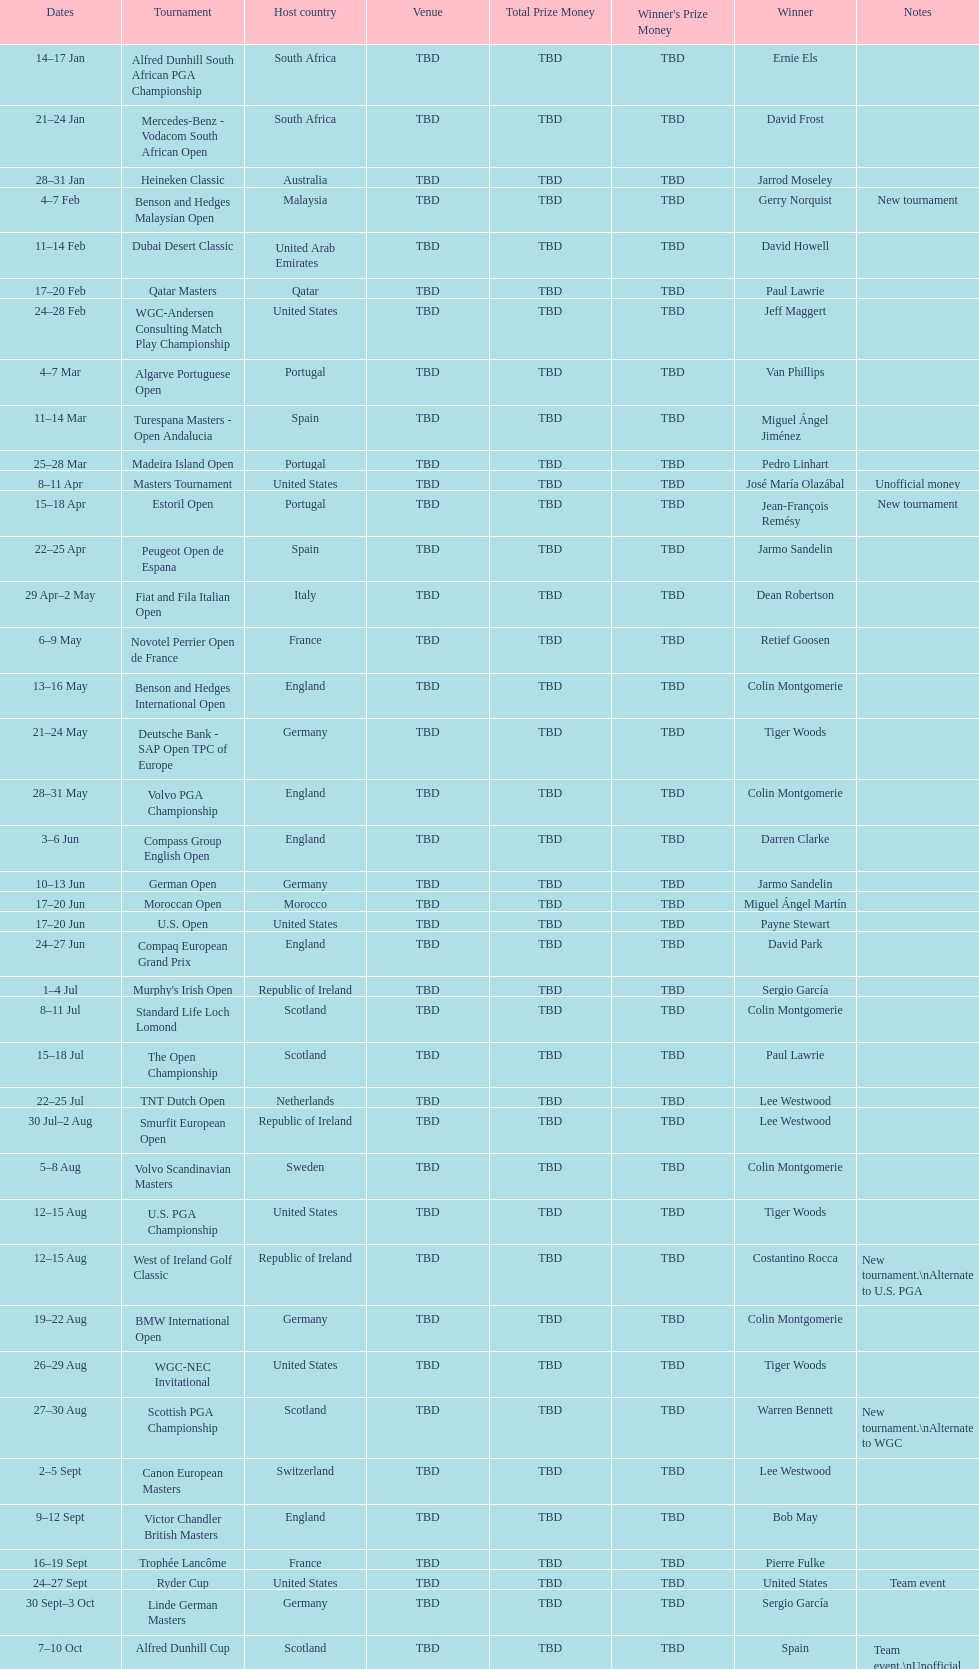I'm looking to parse the entire table for insights. Could you assist me with that? {'header': ['Dates', 'Tournament', 'Host country', 'Venue', 'Total Prize Money', "Winner's Prize Money", 'Winner', 'Notes'], 'rows': [['14–17\xa0Jan', 'Alfred Dunhill South African PGA Championship', 'South Africa', 'TBD', 'TBD', 'TBD', 'Ernie Els', ''], ['21–24\xa0Jan', 'Mercedes-Benz - Vodacom South African Open', 'South Africa', 'TBD', 'TBD', 'TBD', 'David Frost', ''], ['28–31\xa0Jan', 'Heineken Classic', 'Australia', 'TBD', 'TBD', 'TBD', 'Jarrod Moseley', ''], ['4–7\xa0Feb', 'Benson and Hedges Malaysian Open', 'Malaysia', 'TBD', 'TBD', 'TBD', 'Gerry Norquist', 'New tournament'], ['11–14\xa0Feb', 'Dubai Desert Classic', 'United Arab Emirates', 'TBD', 'TBD', 'TBD', 'David Howell', ''], ['17–20\xa0Feb', 'Qatar Masters', 'Qatar', 'TBD', 'TBD', 'TBD', 'Paul Lawrie', ''], ['24–28\xa0Feb', 'WGC-Andersen Consulting Match Play Championship', 'United States', 'TBD', 'TBD', 'TBD', 'Jeff Maggert', ''], ['4–7\xa0Mar', 'Algarve Portuguese Open', 'Portugal', 'TBD', 'TBD', 'TBD', 'Van Phillips', ''], ['11–14\xa0Mar', 'Turespana Masters - Open Andalucia', 'Spain', 'TBD', 'TBD', 'TBD', 'Miguel Ángel Jiménez', ''], ['25–28\xa0Mar', 'Madeira Island Open', 'Portugal', 'TBD', 'TBD', 'TBD', 'Pedro Linhart', ''], ['8–11\xa0Apr', 'Masters Tournament', 'United States', 'TBD', 'TBD', 'TBD', 'José María Olazábal', 'Unofficial money'], ['15–18\xa0Apr', 'Estoril Open', 'Portugal', 'TBD', 'TBD', 'TBD', 'Jean-François Remésy', 'New tournament'], ['22–25\xa0Apr', 'Peugeot Open de Espana', 'Spain', 'TBD', 'TBD', 'TBD', 'Jarmo Sandelin', ''], ['29\xa0Apr–2\xa0May', 'Fiat and Fila Italian Open', 'Italy', 'TBD', 'TBD', 'TBD', 'Dean Robertson', ''], ['6–9\xa0May', 'Novotel Perrier Open de France', 'France', 'TBD', 'TBD', 'TBD', 'Retief Goosen', ''], ['13–16\xa0May', 'Benson and Hedges International Open', 'England', 'TBD', 'TBD', 'TBD', 'Colin Montgomerie', ''], ['21–24\xa0May', 'Deutsche Bank - SAP Open TPC of Europe', 'Germany', 'TBD', 'TBD', 'TBD', 'Tiger Woods', ''], ['28–31\xa0May', 'Volvo PGA Championship', 'England', 'TBD', 'TBD', 'TBD', 'Colin Montgomerie', ''], ['3–6\xa0Jun', 'Compass Group English Open', 'England', 'TBD', 'TBD', 'TBD', 'Darren Clarke', ''], ['10–13\xa0Jun', 'German Open', 'Germany', 'TBD', 'TBD', 'TBD', 'Jarmo Sandelin', ''], ['17–20\xa0Jun', 'Moroccan Open', 'Morocco', 'TBD', 'TBD', 'TBD', 'Miguel Ángel Martín', ''], ['17–20\xa0Jun', 'U.S. Open', 'United States', 'TBD', 'TBD', 'TBD', 'Payne Stewart', ''], ['24–27\xa0Jun', 'Compaq European Grand Prix', 'England', 'TBD', 'TBD', 'TBD', 'David Park', ''], ['1–4\xa0Jul', "Murphy's Irish Open", 'Republic of Ireland', 'TBD', 'TBD', 'TBD', 'Sergio García', ''], ['8–11\xa0Jul', 'Standard Life Loch Lomond', 'Scotland', 'TBD', 'TBD', 'TBD', 'Colin Montgomerie', ''], ['15–18\xa0Jul', 'The Open Championship', 'Scotland', 'TBD', 'TBD', 'TBD', 'Paul Lawrie', ''], ['22–25\xa0Jul', 'TNT Dutch Open', 'Netherlands', 'TBD', 'TBD', 'TBD', 'Lee Westwood', ''], ['30\xa0Jul–2\xa0Aug', 'Smurfit European Open', 'Republic of Ireland', 'TBD', 'TBD', 'TBD', 'Lee Westwood', ''], ['5–8\xa0Aug', 'Volvo Scandinavian Masters', 'Sweden', 'TBD', 'TBD', 'TBD', 'Colin Montgomerie', ''], ['12–15\xa0Aug', 'U.S. PGA Championship', 'United States', 'TBD', 'TBD', 'TBD', 'Tiger Woods', ''], ['12–15\xa0Aug', 'West of Ireland Golf Classic', 'Republic of Ireland', 'TBD', 'TBD', 'TBD', 'Costantino Rocca', 'New tournament.\\nAlternate to U.S. PGA'], ['19–22\xa0Aug', 'BMW International Open', 'Germany', 'TBD', 'TBD', 'TBD', 'Colin Montgomerie', ''], ['26–29\xa0Aug', 'WGC-NEC Invitational', 'United States', 'TBD', 'TBD', 'TBD', 'Tiger Woods', ''], ['27–30\xa0Aug', 'Scottish PGA Championship', 'Scotland', 'TBD', 'TBD', 'TBD', 'Warren Bennett', 'New tournament.\\nAlternate to WGC'], ['2–5\xa0Sept', 'Canon European Masters', 'Switzerland', 'TBD', 'TBD', 'TBD', 'Lee Westwood', ''], ['9–12\xa0Sept', 'Victor Chandler British Masters', 'England', 'TBD', 'TBD', 'TBD', 'Bob May', ''], ['16–19\xa0Sept', 'Trophée Lancôme', 'France', 'TBD', 'TBD', 'TBD', 'Pierre Fulke', ''], ['24–27\xa0Sept', 'Ryder Cup', 'United States', 'TBD', 'TBD', 'TBD', 'United States', 'Team event'], ['30\xa0Sept–3\xa0Oct', 'Linde German Masters', 'Germany', 'TBD', 'TBD', 'TBD', 'Sergio García', ''], ['7–10\xa0Oct', 'Alfred Dunhill Cup', 'Scotland', 'TBD', 'TBD', 'TBD', 'Spain', 'Team event.\\nUnofficial money'], ['14–17\xa0Oct', 'Cisco World Match Play Championship', 'England', 'TBD', 'TBD', 'TBD', 'Colin Montgomerie', 'Unofficial money'], ['14–17\xa0Oct', 'Sarazen World Open', 'Spain', 'TBD', 'TBD', 'TBD', 'Thomas Bjørn', 'New tournament'], ['21–24\xa0Oct', 'Belgacom Open', 'Belgium', 'TBD', 'TBD', 'TBD', 'Robert Karlsson', ''], ['28–31\xa0Oct', 'Volvo Masters', 'Spain', 'TBD', 'TBD', 'TBD', 'Miguel Ángel Jiménez', ''], ['4–7\xa0Nov', 'WGC-American Express Championship', 'Spain', 'TBD', 'TBD', 'TBD', 'Tiger Woods', ''], ['18–21\xa0Nov', 'World Cup of Golf', 'Malaysia', 'TBD', 'TBD', 'TBD', 'United States', 'Team event.\\nUnofficial money']]} Does any country have more than 5 winners? Yes. 